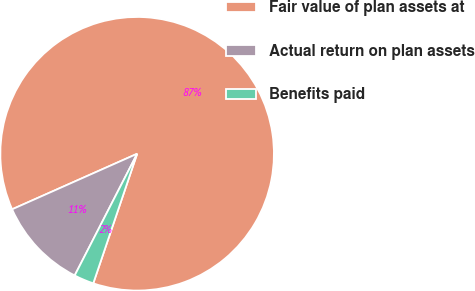Convert chart to OTSL. <chart><loc_0><loc_0><loc_500><loc_500><pie_chart><fcel>Fair value of plan assets at<fcel>Actual return on plan assets<fcel>Benefits paid<nl><fcel>86.85%<fcel>10.8%<fcel>2.35%<nl></chart> 